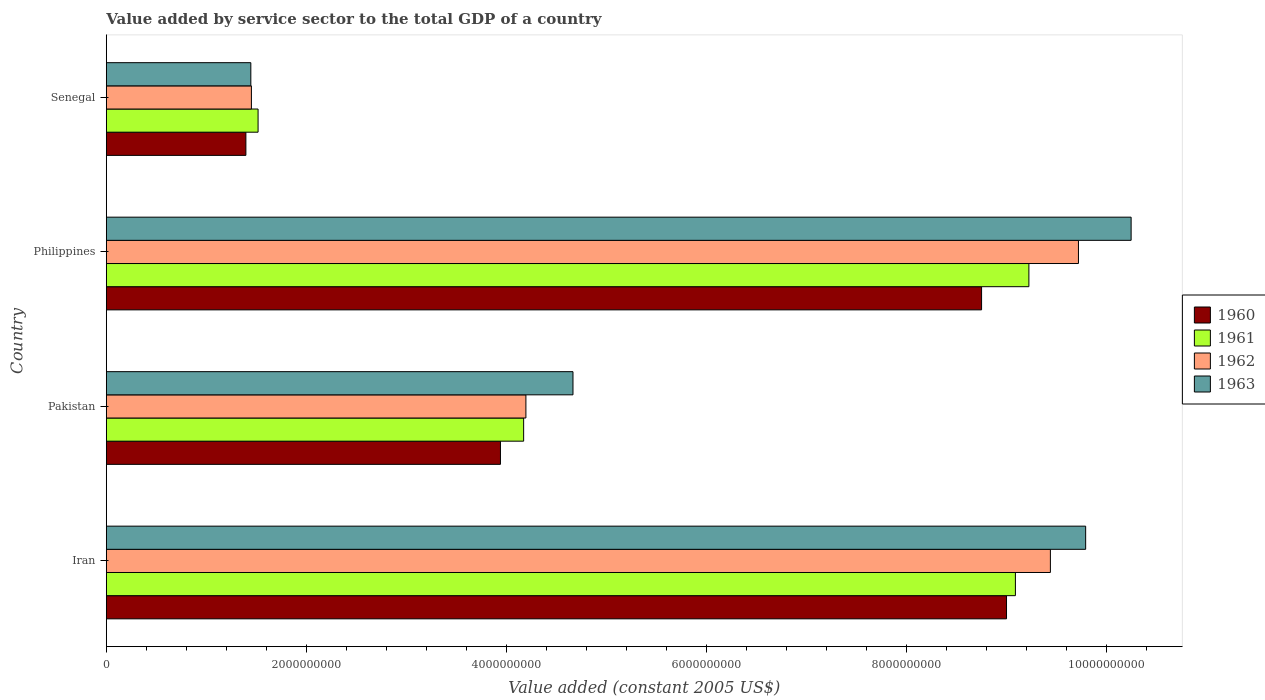How many groups of bars are there?
Offer a very short reply. 4. Are the number of bars per tick equal to the number of legend labels?
Your answer should be very brief. Yes. How many bars are there on the 2nd tick from the top?
Keep it short and to the point. 4. What is the value added by service sector in 1961 in Pakistan?
Keep it short and to the point. 4.17e+09. Across all countries, what is the maximum value added by service sector in 1961?
Make the answer very short. 9.22e+09. Across all countries, what is the minimum value added by service sector in 1962?
Keep it short and to the point. 1.45e+09. In which country was the value added by service sector in 1961 maximum?
Your answer should be very brief. Philippines. In which country was the value added by service sector in 1961 minimum?
Give a very brief answer. Senegal. What is the total value added by service sector in 1961 in the graph?
Make the answer very short. 2.40e+1. What is the difference between the value added by service sector in 1961 in Philippines and that in Senegal?
Provide a short and direct response. 7.70e+09. What is the difference between the value added by service sector in 1963 in Senegal and the value added by service sector in 1961 in Pakistan?
Keep it short and to the point. -2.73e+09. What is the average value added by service sector in 1963 per country?
Ensure brevity in your answer.  6.53e+09. What is the difference between the value added by service sector in 1963 and value added by service sector in 1961 in Senegal?
Provide a succinct answer. -7.25e+07. What is the ratio of the value added by service sector in 1960 in Iran to that in Philippines?
Offer a very short reply. 1.03. What is the difference between the highest and the second highest value added by service sector in 1960?
Provide a succinct answer. 2.49e+08. What is the difference between the highest and the lowest value added by service sector in 1963?
Give a very brief answer. 8.80e+09. Is it the case that in every country, the sum of the value added by service sector in 1961 and value added by service sector in 1963 is greater than the sum of value added by service sector in 1960 and value added by service sector in 1962?
Make the answer very short. No. What does the 3rd bar from the top in Philippines represents?
Your answer should be very brief. 1961. What does the 1st bar from the bottom in Pakistan represents?
Provide a succinct answer. 1960. How many bars are there?
Make the answer very short. 16. Are the values on the major ticks of X-axis written in scientific E-notation?
Provide a succinct answer. No. Does the graph contain grids?
Your answer should be very brief. No. Where does the legend appear in the graph?
Your answer should be compact. Center right. How many legend labels are there?
Ensure brevity in your answer.  4. What is the title of the graph?
Offer a terse response. Value added by service sector to the total GDP of a country. Does "2002" appear as one of the legend labels in the graph?
Make the answer very short. No. What is the label or title of the X-axis?
Keep it short and to the point. Value added (constant 2005 US$). What is the label or title of the Y-axis?
Make the answer very short. Country. What is the Value added (constant 2005 US$) of 1960 in Iran?
Provide a succinct answer. 9.00e+09. What is the Value added (constant 2005 US$) of 1961 in Iran?
Your response must be concise. 9.09e+09. What is the Value added (constant 2005 US$) in 1962 in Iran?
Your answer should be compact. 9.44e+09. What is the Value added (constant 2005 US$) in 1963 in Iran?
Offer a very short reply. 9.79e+09. What is the Value added (constant 2005 US$) of 1960 in Pakistan?
Offer a very short reply. 3.94e+09. What is the Value added (constant 2005 US$) of 1961 in Pakistan?
Offer a terse response. 4.17e+09. What is the Value added (constant 2005 US$) of 1962 in Pakistan?
Offer a terse response. 4.19e+09. What is the Value added (constant 2005 US$) in 1963 in Pakistan?
Make the answer very short. 4.66e+09. What is the Value added (constant 2005 US$) of 1960 in Philippines?
Ensure brevity in your answer.  8.75e+09. What is the Value added (constant 2005 US$) of 1961 in Philippines?
Give a very brief answer. 9.22e+09. What is the Value added (constant 2005 US$) in 1962 in Philippines?
Your answer should be compact. 9.72e+09. What is the Value added (constant 2005 US$) in 1963 in Philippines?
Provide a succinct answer. 1.02e+1. What is the Value added (constant 2005 US$) of 1960 in Senegal?
Make the answer very short. 1.39e+09. What is the Value added (constant 2005 US$) in 1961 in Senegal?
Your answer should be very brief. 1.52e+09. What is the Value added (constant 2005 US$) in 1962 in Senegal?
Your response must be concise. 1.45e+09. What is the Value added (constant 2005 US$) of 1963 in Senegal?
Offer a terse response. 1.44e+09. Across all countries, what is the maximum Value added (constant 2005 US$) in 1960?
Your answer should be compact. 9.00e+09. Across all countries, what is the maximum Value added (constant 2005 US$) in 1961?
Your answer should be compact. 9.22e+09. Across all countries, what is the maximum Value added (constant 2005 US$) in 1962?
Give a very brief answer. 9.72e+09. Across all countries, what is the maximum Value added (constant 2005 US$) of 1963?
Offer a very short reply. 1.02e+1. Across all countries, what is the minimum Value added (constant 2005 US$) of 1960?
Make the answer very short. 1.39e+09. Across all countries, what is the minimum Value added (constant 2005 US$) of 1961?
Keep it short and to the point. 1.52e+09. Across all countries, what is the minimum Value added (constant 2005 US$) in 1962?
Provide a short and direct response. 1.45e+09. Across all countries, what is the minimum Value added (constant 2005 US$) in 1963?
Your answer should be compact. 1.44e+09. What is the total Value added (constant 2005 US$) of 1960 in the graph?
Give a very brief answer. 2.31e+1. What is the total Value added (constant 2005 US$) in 1961 in the graph?
Your response must be concise. 2.40e+1. What is the total Value added (constant 2005 US$) in 1962 in the graph?
Your answer should be compact. 2.48e+1. What is the total Value added (constant 2005 US$) in 1963 in the graph?
Offer a terse response. 2.61e+1. What is the difference between the Value added (constant 2005 US$) of 1960 in Iran and that in Pakistan?
Provide a succinct answer. 5.06e+09. What is the difference between the Value added (constant 2005 US$) of 1961 in Iran and that in Pakistan?
Your answer should be very brief. 4.92e+09. What is the difference between the Value added (constant 2005 US$) of 1962 in Iran and that in Pakistan?
Offer a very short reply. 5.24e+09. What is the difference between the Value added (constant 2005 US$) in 1963 in Iran and that in Pakistan?
Offer a very short reply. 5.12e+09. What is the difference between the Value added (constant 2005 US$) of 1960 in Iran and that in Philippines?
Your response must be concise. 2.49e+08. What is the difference between the Value added (constant 2005 US$) of 1961 in Iran and that in Philippines?
Offer a terse response. -1.35e+08. What is the difference between the Value added (constant 2005 US$) in 1962 in Iran and that in Philippines?
Keep it short and to the point. -2.80e+08. What is the difference between the Value added (constant 2005 US$) in 1963 in Iran and that in Philippines?
Make the answer very short. -4.54e+08. What is the difference between the Value added (constant 2005 US$) of 1960 in Iran and that in Senegal?
Give a very brief answer. 7.60e+09. What is the difference between the Value added (constant 2005 US$) in 1961 in Iran and that in Senegal?
Offer a very short reply. 7.57e+09. What is the difference between the Value added (constant 2005 US$) in 1962 in Iran and that in Senegal?
Offer a terse response. 7.99e+09. What is the difference between the Value added (constant 2005 US$) of 1963 in Iran and that in Senegal?
Give a very brief answer. 8.34e+09. What is the difference between the Value added (constant 2005 US$) of 1960 in Pakistan and that in Philippines?
Provide a short and direct response. -4.81e+09. What is the difference between the Value added (constant 2005 US$) in 1961 in Pakistan and that in Philippines?
Your answer should be very brief. -5.05e+09. What is the difference between the Value added (constant 2005 US$) of 1962 in Pakistan and that in Philippines?
Make the answer very short. -5.52e+09. What is the difference between the Value added (constant 2005 US$) of 1963 in Pakistan and that in Philippines?
Provide a succinct answer. -5.58e+09. What is the difference between the Value added (constant 2005 US$) in 1960 in Pakistan and that in Senegal?
Your answer should be compact. 2.54e+09. What is the difference between the Value added (constant 2005 US$) of 1961 in Pakistan and that in Senegal?
Provide a succinct answer. 2.65e+09. What is the difference between the Value added (constant 2005 US$) of 1962 in Pakistan and that in Senegal?
Offer a terse response. 2.74e+09. What is the difference between the Value added (constant 2005 US$) in 1963 in Pakistan and that in Senegal?
Provide a short and direct response. 3.22e+09. What is the difference between the Value added (constant 2005 US$) in 1960 in Philippines and that in Senegal?
Your answer should be compact. 7.35e+09. What is the difference between the Value added (constant 2005 US$) of 1961 in Philippines and that in Senegal?
Keep it short and to the point. 7.70e+09. What is the difference between the Value added (constant 2005 US$) of 1962 in Philippines and that in Senegal?
Your answer should be compact. 8.27e+09. What is the difference between the Value added (constant 2005 US$) of 1963 in Philippines and that in Senegal?
Provide a succinct answer. 8.80e+09. What is the difference between the Value added (constant 2005 US$) in 1960 in Iran and the Value added (constant 2005 US$) in 1961 in Pakistan?
Your answer should be very brief. 4.83e+09. What is the difference between the Value added (constant 2005 US$) in 1960 in Iran and the Value added (constant 2005 US$) in 1962 in Pakistan?
Offer a very short reply. 4.80e+09. What is the difference between the Value added (constant 2005 US$) in 1960 in Iran and the Value added (constant 2005 US$) in 1963 in Pakistan?
Provide a short and direct response. 4.33e+09. What is the difference between the Value added (constant 2005 US$) of 1961 in Iran and the Value added (constant 2005 US$) of 1962 in Pakistan?
Make the answer very short. 4.89e+09. What is the difference between the Value added (constant 2005 US$) in 1961 in Iran and the Value added (constant 2005 US$) in 1963 in Pakistan?
Offer a very short reply. 4.42e+09. What is the difference between the Value added (constant 2005 US$) in 1962 in Iran and the Value added (constant 2005 US$) in 1963 in Pakistan?
Your answer should be very brief. 4.77e+09. What is the difference between the Value added (constant 2005 US$) in 1960 in Iran and the Value added (constant 2005 US$) in 1961 in Philippines?
Offer a very short reply. -2.24e+08. What is the difference between the Value added (constant 2005 US$) in 1960 in Iran and the Value added (constant 2005 US$) in 1962 in Philippines?
Your answer should be compact. -7.19e+08. What is the difference between the Value added (constant 2005 US$) of 1960 in Iran and the Value added (constant 2005 US$) of 1963 in Philippines?
Your answer should be very brief. -1.25e+09. What is the difference between the Value added (constant 2005 US$) of 1961 in Iran and the Value added (constant 2005 US$) of 1962 in Philippines?
Your answer should be compact. -6.30e+08. What is the difference between the Value added (constant 2005 US$) in 1961 in Iran and the Value added (constant 2005 US$) in 1963 in Philippines?
Make the answer very short. -1.16e+09. What is the difference between the Value added (constant 2005 US$) of 1962 in Iran and the Value added (constant 2005 US$) of 1963 in Philippines?
Offer a terse response. -8.07e+08. What is the difference between the Value added (constant 2005 US$) in 1960 in Iran and the Value added (constant 2005 US$) in 1961 in Senegal?
Your response must be concise. 7.48e+09. What is the difference between the Value added (constant 2005 US$) in 1960 in Iran and the Value added (constant 2005 US$) in 1962 in Senegal?
Offer a very short reply. 7.55e+09. What is the difference between the Value added (constant 2005 US$) of 1960 in Iran and the Value added (constant 2005 US$) of 1963 in Senegal?
Offer a terse response. 7.55e+09. What is the difference between the Value added (constant 2005 US$) in 1961 in Iran and the Value added (constant 2005 US$) in 1962 in Senegal?
Your answer should be compact. 7.64e+09. What is the difference between the Value added (constant 2005 US$) of 1961 in Iran and the Value added (constant 2005 US$) of 1963 in Senegal?
Offer a terse response. 7.64e+09. What is the difference between the Value added (constant 2005 US$) of 1962 in Iran and the Value added (constant 2005 US$) of 1963 in Senegal?
Your answer should be very brief. 7.99e+09. What is the difference between the Value added (constant 2005 US$) of 1960 in Pakistan and the Value added (constant 2005 US$) of 1961 in Philippines?
Make the answer very short. -5.28e+09. What is the difference between the Value added (constant 2005 US$) in 1960 in Pakistan and the Value added (constant 2005 US$) in 1962 in Philippines?
Give a very brief answer. -5.78e+09. What is the difference between the Value added (constant 2005 US$) in 1960 in Pakistan and the Value added (constant 2005 US$) in 1963 in Philippines?
Provide a short and direct response. -6.30e+09. What is the difference between the Value added (constant 2005 US$) of 1961 in Pakistan and the Value added (constant 2005 US$) of 1962 in Philippines?
Your response must be concise. -5.55e+09. What is the difference between the Value added (constant 2005 US$) of 1961 in Pakistan and the Value added (constant 2005 US$) of 1963 in Philippines?
Give a very brief answer. -6.07e+09. What is the difference between the Value added (constant 2005 US$) in 1962 in Pakistan and the Value added (constant 2005 US$) in 1963 in Philippines?
Give a very brief answer. -6.05e+09. What is the difference between the Value added (constant 2005 US$) in 1960 in Pakistan and the Value added (constant 2005 US$) in 1961 in Senegal?
Provide a short and direct response. 2.42e+09. What is the difference between the Value added (constant 2005 US$) of 1960 in Pakistan and the Value added (constant 2005 US$) of 1962 in Senegal?
Your response must be concise. 2.49e+09. What is the difference between the Value added (constant 2005 US$) in 1960 in Pakistan and the Value added (constant 2005 US$) in 1963 in Senegal?
Provide a short and direct response. 2.49e+09. What is the difference between the Value added (constant 2005 US$) of 1961 in Pakistan and the Value added (constant 2005 US$) of 1962 in Senegal?
Make the answer very short. 2.72e+09. What is the difference between the Value added (constant 2005 US$) in 1961 in Pakistan and the Value added (constant 2005 US$) in 1963 in Senegal?
Your answer should be very brief. 2.73e+09. What is the difference between the Value added (constant 2005 US$) of 1962 in Pakistan and the Value added (constant 2005 US$) of 1963 in Senegal?
Offer a very short reply. 2.75e+09. What is the difference between the Value added (constant 2005 US$) of 1960 in Philippines and the Value added (constant 2005 US$) of 1961 in Senegal?
Keep it short and to the point. 7.23e+09. What is the difference between the Value added (constant 2005 US$) in 1960 in Philippines and the Value added (constant 2005 US$) in 1962 in Senegal?
Make the answer very short. 7.30e+09. What is the difference between the Value added (constant 2005 US$) of 1960 in Philippines and the Value added (constant 2005 US$) of 1963 in Senegal?
Provide a short and direct response. 7.30e+09. What is the difference between the Value added (constant 2005 US$) of 1961 in Philippines and the Value added (constant 2005 US$) of 1962 in Senegal?
Your response must be concise. 7.77e+09. What is the difference between the Value added (constant 2005 US$) in 1961 in Philippines and the Value added (constant 2005 US$) in 1963 in Senegal?
Provide a short and direct response. 7.78e+09. What is the difference between the Value added (constant 2005 US$) of 1962 in Philippines and the Value added (constant 2005 US$) of 1963 in Senegal?
Ensure brevity in your answer.  8.27e+09. What is the average Value added (constant 2005 US$) in 1960 per country?
Your answer should be very brief. 5.77e+09. What is the average Value added (constant 2005 US$) of 1961 per country?
Make the answer very short. 6.00e+09. What is the average Value added (constant 2005 US$) in 1962 per country?
Keep it short and to the point. 6.20e+09. What is the average Value added (constant 2005 US$) in 1963 per country?
Your answer should be compact. 6.53e+09. What is the difference between the Value added (constant 2005 US$) in 1960 and Value added (constant 2005 US$) in 1961 in Iran?
Provide a short and direct response. -8.88e+07. What is the difference between the Value added (constant 2005 US$) of 1960 and Value added (constant 2005 US$) of 1962 in Iran?
Provide a short and direct response. -4.39e+08. What is the difference between the Value added (constant 2005 US$) in 1960 and Value added (constant 2005 US$) in 1963 in Iran?
Your response must be concise. -7.91e+08. What is the difference between the Value added (constant 2005 US$) of 1961 and Value added (constant 2005 US$) of 1962 in Iran?
Ensure brevity in your answer.  -3.50e+08. What is the difference between the Value added (constant 2005 US$) in 1961 and Value added (constant 2005 US$) in 1963 in Iran?
Give a very brief answer. -7.02e+08. What is the difference between the Value added (constant 2005 US$) in 1962 and Value added (constant 2005 US$) in 1963 in Iran?
Offer a terse response. -3.52e+08. What is the difference between the Value added (constant 2005 US$) in 1960 and Value added (constant 2005 US$) in 1961 in Pakistan?
Your answer should be compact. -2.32e+08. What is the difference between the Value added (constant 2005 US$) in 1960 and Value added (constant 2005 US$) in 1962 in Pakistan?
Provide a succinct answer. -2.54e+08. What is the difference between the Value added (constant 2005 US$) in 1960 and Value added (constant 2005 US$) in 1963 in Pakistan?
Keep it short and to the point. -7.25e+08. What is the difference between the Value added (constant 2005 US$) in 1961 and Value added (constant 2005 US$) in 1962 in Pakistan?
Keep it short and to the point. -2.26e+07. What is the difference between the Value added (constant 2005 US$) of 1961 and Value added (constant 2005 US$) of 1963 in Pakistan?
Provide a short and direct response. -4.93e+08. What is the difference between the Value added (constant 2005 US$) of 1962 and Value added (constant 2005 US$) of 1963 in Pakistan?
Your answer should be very brief. -4.71e+08. What is the difference between the Value added (constant 2005 US$) of 1960 and Value added (constant 2005 US$) of 1961 in Philippines?
Offer a terse response. -4.73e+08. What is the difference between the Value added (constant 2005 US$) in 1960 and Value added (constant 2005 US$) in 1962 in Philippines?
Give a very brief answer. -9.68e+08. What is the difference between the Value added (constant 2005 US$) in 1960 and Value added (constant 2005 US$) in 1963 in Philippines?
Provide a short and direct response. -1.49e+09. What is the difference between the Value added (constant 2005 US$) of 1961 and Value added (constant 2005 US$) of 1962 in Philippines?
Ensure brevity in your answer.  -4.95e+08. What is the difference between the Value added (constant 2005 US$) in 1961 and Value added (constant 2005 US$) in 1963 in Philippines?
Give a very brief answer. -1.02e+09. What is the difference between the Value added (constant 2005 US$) of 1962 and Value added (constant 2005 US$) of 1963 in Philippines?
Ensure brevity in your answer.  -5.27e+08. What is the difference between the Value added (constant 2005 US$) of 1960 and Value added (constant 2005 US$) of 1961 in Senegal?
Your answer should be very brief. -1.22e+08. What is the difference between the Value added (constant 2005 US$) in 1960 and Value added (constant 2005 US$) in 1962 in Senegal?
Keep it short and to the point. -5.52e+07. What is the difference between the Value added (constant 2005 US$) of 1960 and Value added (constant 2005 US$) of 1963 in Senegal?
Your response must be concise. -4.94e+07. What is the difference between the Value added (constant 2005 US$) in 1961 and Value added (constant 2005 US$) in 1962 in Senegal?
Keep it short and to the point. 6.67e+07. What is the difference between the Value added (constant 2005 US$) of 1961 and Value added (constant 2005 US$) of 1963 in Senegal?
Your answer should be very brief. 7.25e+07. What is the difference between the Value added (constant 2005 US$) in 1962 and Value added (constant 2005 US$) in 1963 in Senegal?
Give a very brief answer. 5.77e+06. What is the ratio of the Value added (constant 2005 US$) of 1960 in Iran to that in Pakistan?
Keep it short and to the point. 2.28. What is the ratio of the Value added (constant 2005 US$) in 1961 in Iran to that in Pakistan?
Provide a succinct answer. 2.18. What is the ratio of the Value added (constant 2005 US$) in 1962 in Iran to that in Pakistan?
Provide a short and direct response. 2.25. What is the ratio of the Value added (constant 2005 US$) in 1963 in Iran to that in Pakistan?
Your answer should be very brief. 2.1. What is the ratio of the Value added (constant 2005 US$) of 1960 in Iran to that in Philippines?
Keep it short and to the point. 1.03. What is the ratio of the Value added (constant 2005 US$) of 1961 in Iran to that in Philippines?
Offer a terse response. 0.99. What is the ratio of the Value added (constant 2005 US$) in 1962 in Iran to that in Philippines?
Provide a short and direct response. 0.97. What is the ratio of the Value added (constant 2005 US$) of 1963 in Iran to that in Philippines?
Your response must be concise. 0.96. What is the ratio of the Value added (constant 2005 US$) in 1960 in Iran to that in Senegal?
Offer a very short reply. 6.45. What is the ratio of the Value added (constant 2005 US$) of 1961 in Iran to that in Senegal?
Offer a terse response. 5.99. What is the ratio of the Value added (constant 2005 US$) of 1962 in Iran to that in Senegal?
Provide a short and direct response. 6.51. What is the ratio of the Value added (constant 2005 US$) of 1963 in Iran to that in Senegal?
Your response must be concise. 6.78. What is the ratio of the Value added (constant 2005 US$) of 1960 in Pakistan to that in Philippines?
Offer a very short reply. 0.45. What is the ratio of the Value added (constant 2005 US$) in 1961 in Pakistan to that in Philippines?
Provide a succinct answer. 0.45. What is the ratio of the Value added (constant 2005 US$) in 1962 in Pakistan to that in Philippines?
Ensure brevity in your answer.  0.43. What is the ratio of the Value added (constant 2005 US$) of 1963 in Pakistan to that in Philippines?
Keep it short and to the point. 0.46. What is the ratio of the Value added (constant 2005 US$) of 1960 in Pakistan to that in Senegal?
Offer a very short reply. 2.82. What is the ratio of the Value added (constant 2005 US$) in 1961 in Pakistan to that in Senegal?
Provide a succinct answer. 2.75. What is the ratio of the Value added (constant 2005 US$) of 1962 in Pakistan to that in Senegal?
Make the answer very short. 2.89. What is the ratio of the Value added (constant 2005 US$) in 1963 in Pakistan to that in Senegal?
Your response must be concise. 3.23. What is the ratio of the Value added (constant 2005 US$) in 1960 in Philippines to that in Senegal?
Give a very brief answer. 6.27. What is the ratio of the Value added (constant 2005 US$) in 1961 in Philippines to that in Senegal?
Provide a short and direct response. 6.08. What is the ratio of the Value added (constant 2005 US$) of 1962 in Philippines to that in Senegal?
Your response must be concise. 6.7. What is the ratio of the Value added (constant 2005 US$) in 1963 in Philippines to that in Senegal?
Give a very brief answer. 7.09. What is the difference between the highest and the second highest Value added (constant 2005 US$) in 1960?
Your answer should be compact. 2.49e+08. What is the difference between the highest and the second highest Value added (constant 2005 US$) of 1961?
Offer a very short reply. 1.35e+08. What is the difference between the highest and the second highest Value added (constant 2005 US$) in 1962?
Keep it short and to the point. 2.80e+08. What is the difference between the highest and the second highest Value added (constant 2005 US$) in 1963?
Ensure brevity in your answer.  4.54e+08. What is the difference between the highest and the lowest Value added (constant 2005 US$) of 1960?
Provide a succinct answer. 7.60e+09. What is the difference between the highest and the lowest Value added (constant 2005 US$) in 1961?
Provide a succinct answer. 7.70e+09. What is the difference between the highest and the lowest Value added (constant 2005 US$) in 1962?
Offer a terse response. 8.27e+09. What is the difference between the highest and the lowest Value added (constant 2005 US$) of 1963?
Your response must be concise. 8.80e+09. 